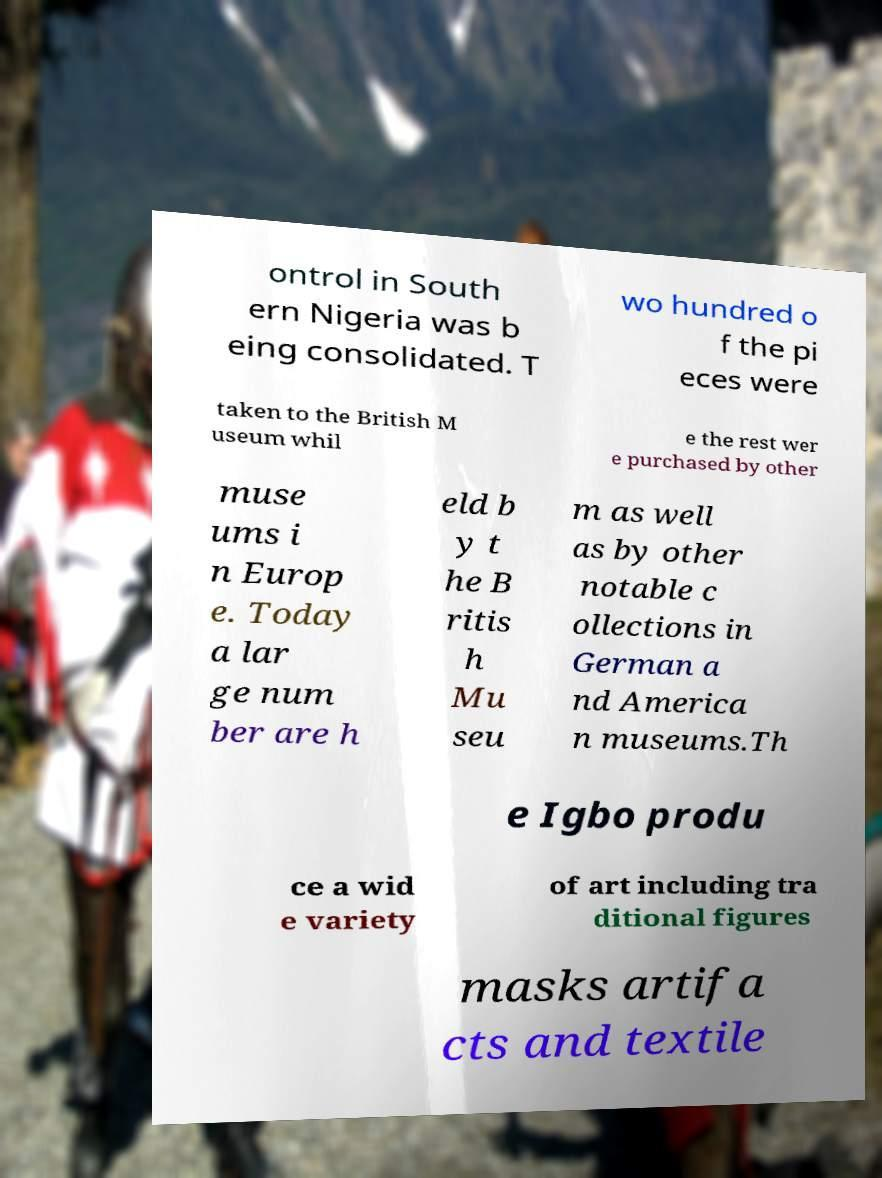Please read and relay the text visible in this image. What does it say? ontrol in South ern Nigeria was b eing consolidated. T wo hundred o f the pi eces were taken to the British M useum whil e the rest wer e purchased by other muse ums i n Europ e. Today a lar ge num ber are h eld b y t he B ritis h Mu seu m as well as by other notable c ollections in German a nd America n museums.Th e Igbo produ ce a wid e variety of art including tra ditional figures masks artifa cts and textile 